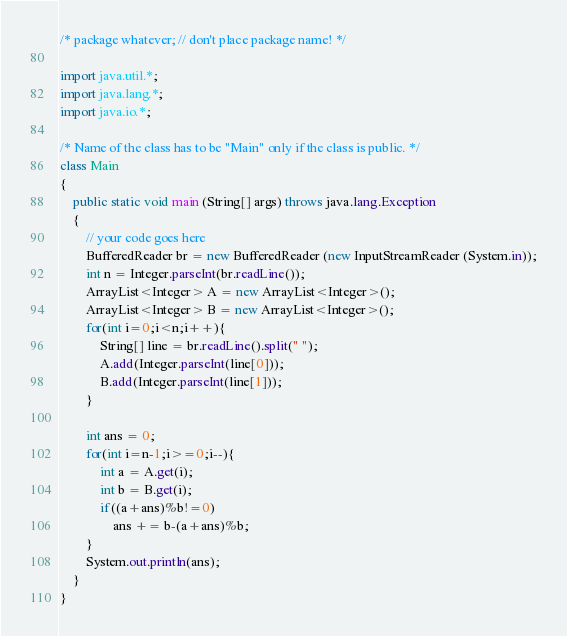Convert code to text. <code><loc_0><loc_0><loc_500><loc_500><_Java_>/* package whatever; // don't place package name! */

import java.util.*;
import java.lang.*;
import java.io.*;

/* Name of the class has to be "Main" only if the class is public. */
class Main
{
	public static void main (String[] args) throws java.lang.Exception
	{
		// your code goes here
		BufferedReader br = new BufferedReader (new InputStreamReader (System.in));
		int n = Integer.parseInt(br.readLine());
		ArrayList<Integer> A = new ArrayList<Integer>();
		ArrayList<Integer> B = new ArrayList<Integer>();
		for(int i=0;i<n;i++){
		    String[] line = br.readLine().split(" ");
		    A.add(Integer.parseInt(line[0]));
		    B.add(Integer.parseInt(line[1]));
		}
		
		int ans = 0;
		for(int i=n-1;i>=0;i--){
		    int a = A.get(i);
		    int b = B.get(i);
		    if((a+ans)%b!=0)
    		    ans += b-(a+ans)%b;
		}
		System.out.println(ans);
	}
}</code> 